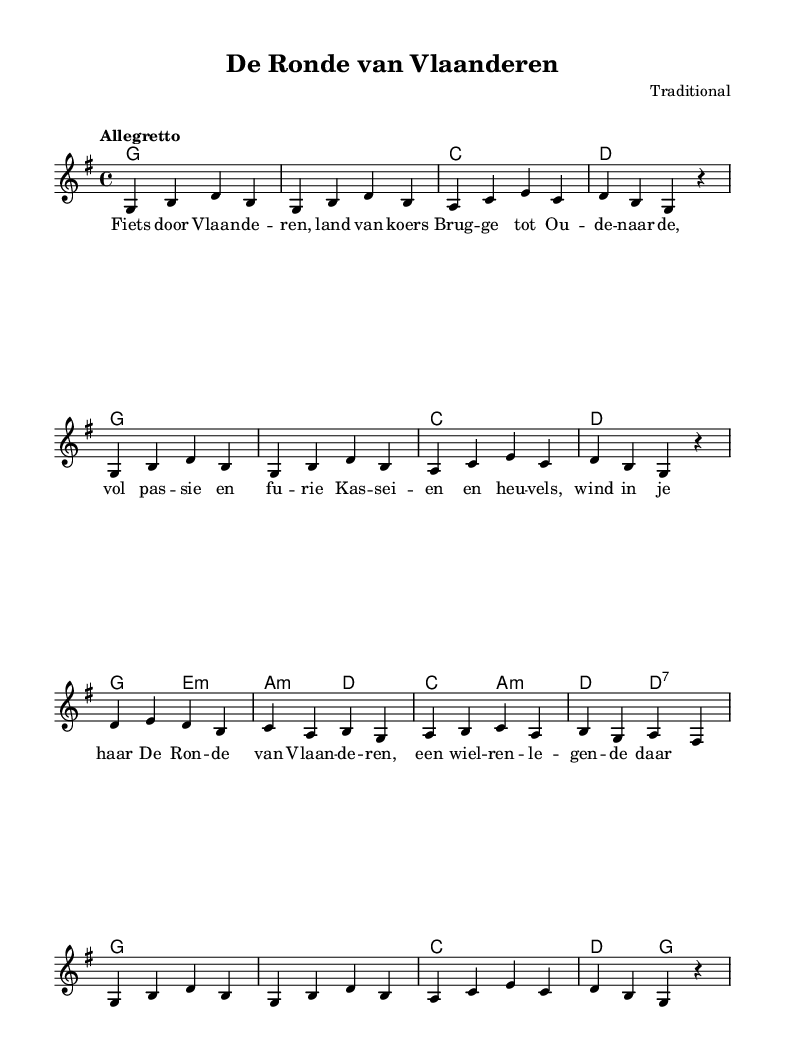What is the key signature of this music? The key signature is indicated at the beginning of the score and shows one sharp, indicating it is in G major.
Answer: G major What is the time signature of this music? The time signature is found at the beginning of the score, using the fraction format. Here it shows 4 over 4, which represents common time.
Answer: 4/4 What is the tempo marking for this piece? The tempo marking is indicated directly above the staff and shows "Allegretto," which defines the speed of the piece as moderately fast.
Answer: Allegretto How many measures are in the melody section? Counting the musical notation between the bar lines, there are a total of 16 measures in the melody section.
Answer: 16 Which chords are used in the first four measures? The first four measures contain the chords G, G, C, and D, which are shown in the chord names section.
Answer: G, G, C, D What is the last lyric line of the verse? The last line of the verse is clearly presented in the lyrics section, which ends with "een wiel-ren-le-gen-de daar."
Answer: een wiel-ren-le-gen-de daar What is the phrase that describes the cycling theme found in this song? The lyrics reflect the cycling theme by referencing "Fiets door Vlaanderen," which translates to cycling through Flanders, celebrating the cycling culture.
Answer: Fiets door Vlaanderen 